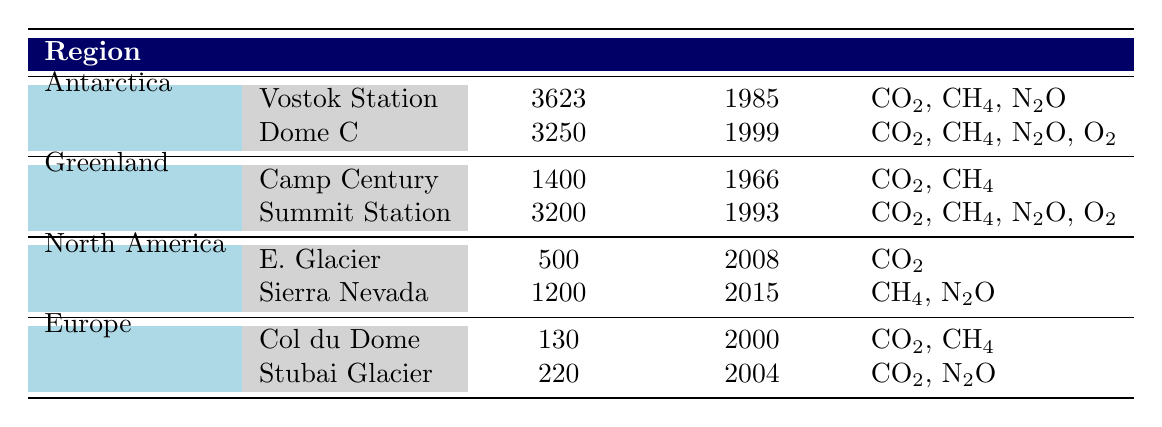What is the depth of the Vostok Station? The table shows that for Vostok Station in Antarctica, the depth is listed as 3623 meters.
Answer: 3623 m Which ice core site was drilled in 2004? Looking at the table, the site drilled in 2004 is Stubai Glacier in Europe.
Answer: Stubai Glacier How many gases were analyzed at Dome C? At Dome C, there are four gases listed: CO2, CH4, N2O, and O2.
Answer: 4 Is there any location in North America where only CO2 was analyzed? The table shows that E. Glacier in North America has only CO2 listed as the analyzed gas, making the description accurate.
Answer: Yes What is the total depth of all ice core sites in Greenland? The depths for Greenland sites are Camp Century (1400 m) and Summit Station (3200 m). Adding these gives 1400 + 3200 = 4600 m as the total depth.
Answer: 4600 m Which region has the deepest ice core drill site? Vostok Station in Antarctica has the deepest depth listed in the table at 3623 m, making it the deepest site.
Answer: Antarctica Did all sites in Europe analyze N2O? Checking the gases analyzed for both sites in Europe, Col du Dome (gases are CO2 and CH4) and Stubai Glacier (gases are CO2 and N2O), it is clear not all sites have N2O, as Col du Dome lacks it.
Answer: No What is the average drilling year for the sites in Antarctica? The years drilled in Antarctica are 1985 (Vostok Station) and 1999 (Dome C). Adding them gives 1985 + 1999 = 3984, then dividing by 2 gives an average year of 1992.
Answer: 1992 